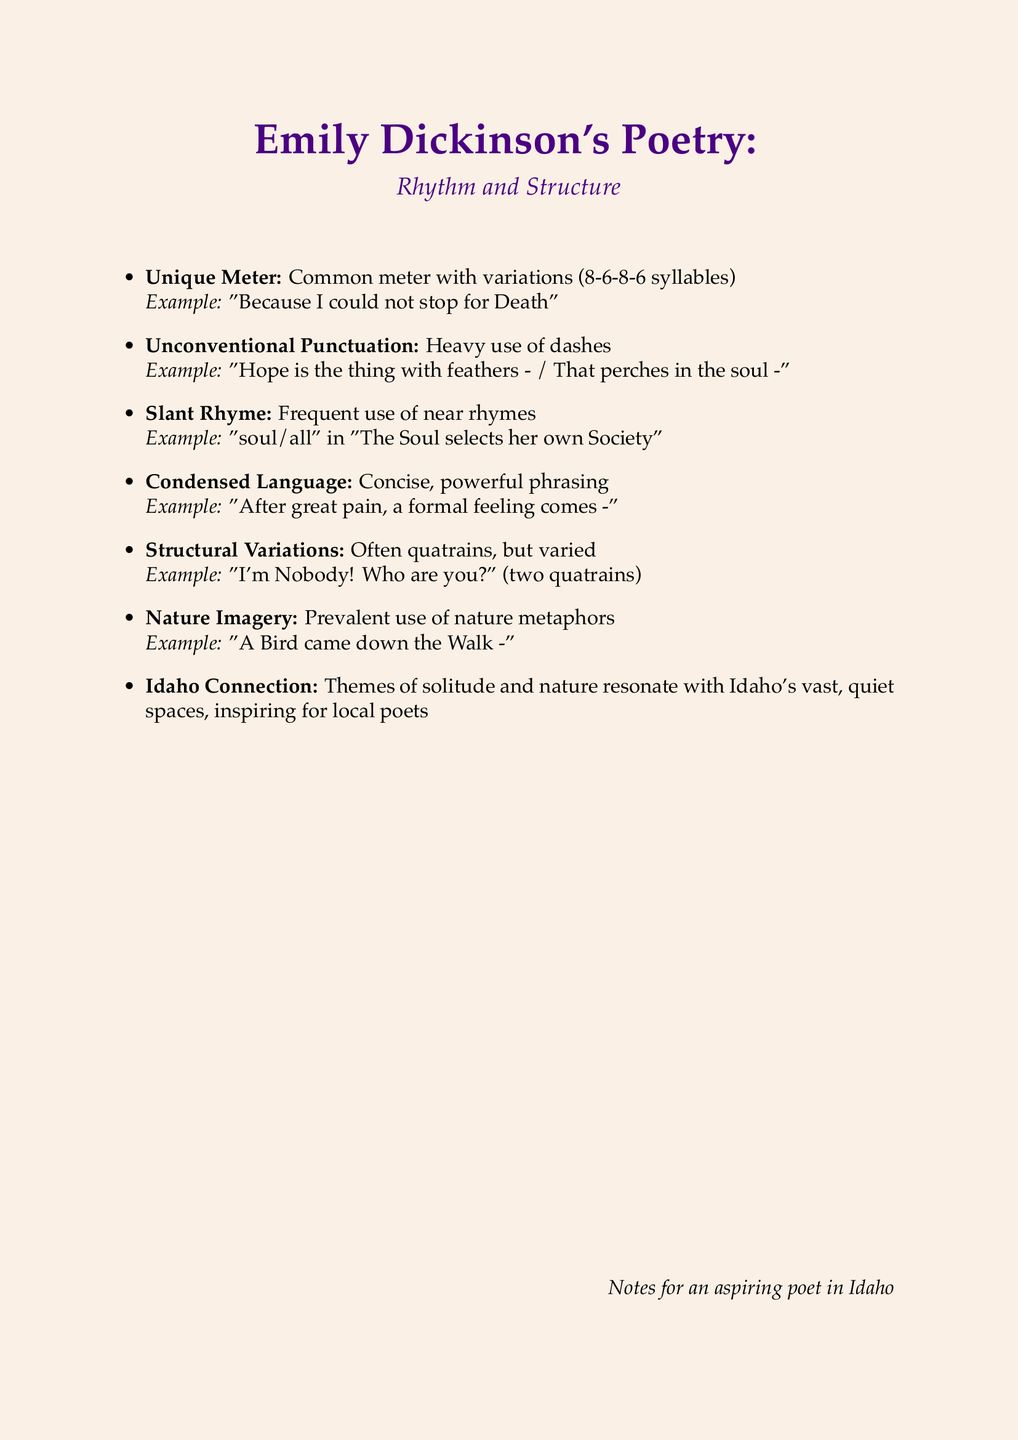What meter does Dickinson often use? The document states that Dickinson often used common meter, which consists of alternating lines of 8 and 6 syllables.
Answer: common meter What example is given for unique meter? The example provided in the document for unique meter is “Because I could not stop for Death.”
Answer: Because I could not stop for Death How does Dickinson emphasize pauses in her poetry? The document mentions that Dickinson uses heavy dashes for emphasis and pauses.
Answer: dashes What is a characteristic of Dickinson's rhyming style? The document states that she frequently uses near or slant rhymes.
Answer: slant rhymes Which imagery is prevalent in Dickinson's poetry? The document indicates that there is a prevalent use of nature metaphors in her poetry.
Answer: nature metaphors What example is given illustrating nature imagery? The provided example in the document for nature imagery is “A Bird came down the Walk.”
Answer: A Bird came down the Walk In what way do Dickinson's themes resonate with Idaho? The document describes her themes of solitude and nature as resonating with Idaho's vast, quiet spaces.
Answer: solitude and nature What kind of variations does Dickinson employ in her structure? The document notes that Dickinson often used quatrains, but she also experimented with other forms.
Answer: quatrains How does Dickinson's language style appear in her poetry? The document describes her language style as concise and powerful phrasing.
Answer: concise, powerful phrasing 